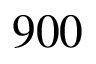Convert formula to latex. <formula><loc_0><loc_0><loc_500><loc_500>9 0 0</formula> 